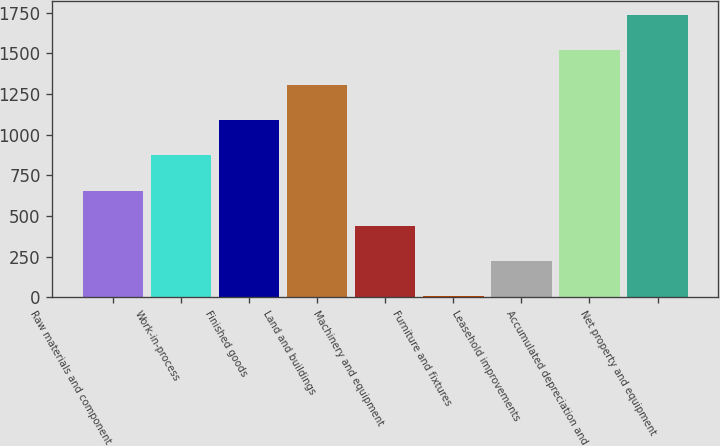<chart> <loc_0><loc_0><loc_500><loc_500><bar_chart><fcel>Raw materials and component<fcel>Work-in-process<fcel>Finished goods<fcel>Land and buildings<fcel>Machinery and equipment<fcel>Furniture and fixtures<fcel>Leasehold improvements<fcel>Accumulated depreciation and<fcel>Net property and equipment<nl><fcel>656.8<fcel>872.4<fcel>1088<fcel>1303.6<fcel>441.2<fcel>10<fcel>225.6<fcel>1519.2<fcel>1734.8<nl></chart> 